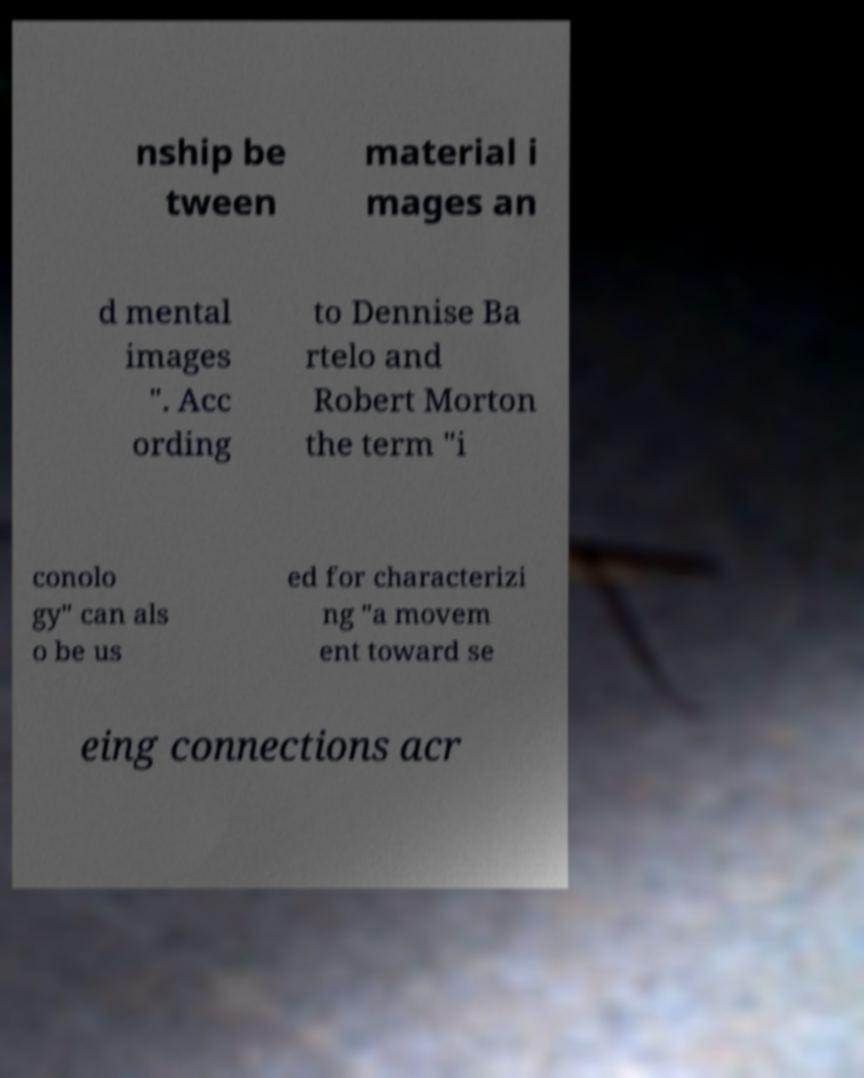There's text embedded in this image that I need extracted. Can you transcribe it verbatim? nship be tween material i mages an d mental images ". Acc ording to Dennise Ba rtelo and Robert Morton the term "i conolo gy" can als o be us ed for characterizi ng "a movem ent toward se eing connections acr 